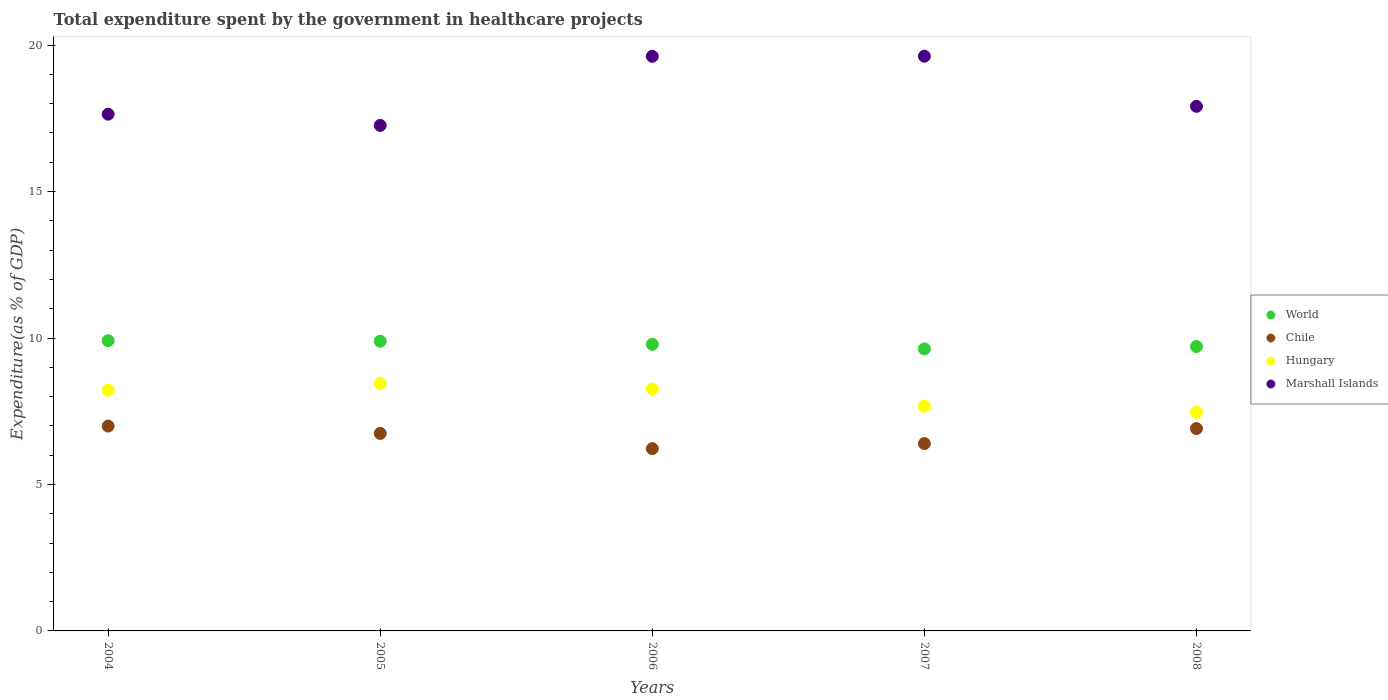How many different coloured dotlines are there?
Offer a very short reply. 4. Is the number of dotlines equal to the number of legend labels?
Provide a succinct answer. Yes. What is the total expenditure spent by the government in healthcare projects in Hungary in 2007?
Keep it short and to the point. 7.67. Across all years, what is the maximum total expenditure spent by the government in healthcare projects in Hungary?
Your answer should be compact. 8.45. Across all years, what is the minimum total expenditure spent by the government in healthcare projects in Marshall Islands?
Your answer should be compact. 17.26. What is the total total expenditure spent by the government in healthcare projects in Marshall Islands in the graph?
Your response must be concise. 92.04. What is the difference between the total expenditure spent by the government in healthcare projects in Chile in 2007 and that in 2008?
Provide a succinct answer. -0.51. What is the difference between the total expenditure spent by the government in healthcare projects in Marshall Islands in 2005 and the total expenditure spent by the government in healthcare projects in World in 2007?
Offer a terse response. 7.63. What is the average total expenditure spent by the government in healthcare projects in Chile per year?
Your answer should be compact. 6.65. In the year 2005, what is the difference between the total expenditure spent by the government in healthcare projects in World and total expenditure spent by the government in healthcare projects in Hungary?
Your response must be concise. 1.45. In how many years, is the total expenditure spent by the government in healthcare projects in Chile greater than 18 %?
Make the answer very short. 0. What is the ratio of the total expenditure spent by the government in healthcare projects in Marshall Islands in 2007 to that in 2008?
Your answer should be very brief. 1.1. Is the difference between the total expenditure spent by the government in healthcare projects in World in 2006 and 2007 greater than the difference between the total expenditure spent by the government in healthcare projects in Hungary in 2006 and 2007?
Your answer should be compact. No. What is the difference between the highest and the second highest total expenditure spent by the government in healthcare projects in World?
Offer a terse response. 0.02. What is the difference between the highest and the lowest total expenditure spent by the government in healthcare projects in Marshall Islands?
Make the answer very short. 2.36. Is the sum of the total expenditure spent by the government in healthcare projects in Chile in 2006 and 2008 greater than the maximum total expenditure spent by the government in healthcare projects in Hungary across all years?
Make the answer very short. Yes. Is it the case that in every year, the sum of the total expenditure spent by the government in healthcare projects in Chile and total expenditure spent by the government in healthcare projects in Marshall Islands  is greater than the total expenditure spent by the government in healthcare projects in Hungary?
Ensure brevity in your answer.  Yes. Does the total expenditure spent by the government in healthcare projects in World monotonically increase over the years?
Provide a succinct answer. No. Is the total expenditure spent by the government in healthcare projects in Chile strictly greater than the total expenditure spent by the government in healthcare projects in World over the years?
Give a very brief answer. No. Is the total expenditure spent by the government in healthcare projects in Chile strictly less than the total expenditure spent by the government in healthcare projects in Hungary over the years?
Your response must be concise. Yes. Are the values on the major ticks of Y-axis written in scientific E-notation?
Give a very brief answer. No. Does the graph contain grids?
Make the answer very short. No. Where does the legend appear in the graph?
Your answer should be very brief. Center right. How are the legend labels stacked?
Make the answer very short. Vertical. What is the title of the graph?
Your answer should be compact. Total expenditure spent by the government in healthcare projects. What is the label or title of the Y-axis?
Provide a short and direct response. Expenditure(as % of GDP). What is the Expenditure(as % of GDP) of World in 2004?
Ensure brevity in your answer.  9.91. What is the Expenditure(as % of GDP) of Chile in 2004?
Give a very brief answer. 6.99. What is the Expenditure(as % of GDP) of Hungary in 2004?
Offer a very short reply. 8.22. What is the Expenditure(as % of GDP) of Marshall Islands in 2004?
Ensure brevity in your answer.  17.64. What is the Expenditure(as % of GDP) of World in 2005?
Ensure brevity in your answer.  9.89. What is the Expenditure(as % of GDP) in Chile in 2005?
Keep it short and to the point. 6.74. What is the Expenditure(as % of GDP) in Hungary in 2005?
Keep it short and to the point. 8.45. What is the Expenditure(as % of GDP) in Marshall Islands in 2005?
Make the answer very short. 17.26. What is the Expenditure(as % of GDP) of World in 2006?
Provide a succinct answer. 9.78. What is the Expenditure(as % of GDP) in Chile in 2006?
Give a very brief answer. 6.22. What is the Expenditure(as % of GDP) of Hungary in 2006?
Your answer should be very brief. 8.26. What is the Expenditure(as % of GDP) in Marshall Islands in 2006?
Provide a succinct answer. 19.62. What is the Expenditure(as % of GDP) of World in 2007?
Give a very brief answer. 9.63. What is the Expenditure(as % of GDP) in Chile in 2007?
Your answer should be very brief. 6.4. What is the Expenditure(as % of GDP) in Hungary in 2007?
Your answer should be compact. 7.67. What is the Expenditure(as % of GDP) of Marshall Islands in 2007?
Give a very brief answer. 19.62. What is the Expenditure(as % of GDP) in World in 2008?
Your answer should be very brief. 9.71. What is the Expenditure(as % of GDP) in Chile in 2008?
Offer a terse response. 6.91. What is the Expenditure(as % of GDP) in Hungary in 2008?
Give a very brief answer. 7.46. What is the Expenditure(as % of GDP) in Marshall Islands in 2008?
Your answer should be compact. 17.91. Across all years, what is the maximum Expenditure(as % of GDP) of World?
Offer a very short reply. 9.91. Across all years, what is the maximum Expenditure(as % of GDP) of Chile?
Provide a succinct answer. 6.99. Across all years, what is the maximum Expenditure(as % of GDP) in Hungary?
Provide a succinct answer. 8.45. Across all years, what is the maximum Expenditure(as % of GDP) in Marshall Islands?
Your answer should be very brief. 19.62. Across all years, what is the minimum Expenditure(as % of GDP) of World?
Make the answer very short. 9.63. Across all years, what is the minimum Expenditure(as % of GDP) of Chile?
Provide a short and direct response. 6.22. Across all years, what is the minimum Expenditure(as % of GDP) in Hungary?
Your answer should be very brief. 7.46. Across all years, what is the minimum Expenditure(as % of GDP) in Marshall Islands?
Provide a short and direct response. 17.26. What is the total Expenditure(as % of GDP) of World in the graph?
Your answer should be very brief. 48.92. What is the total Expenditure(as % of GDP) of Chile in the graph?
Your answer should be very brief. 33.26. What is the total Expenditure(as % of GDP) in Hungary in the graph?
Offer a terse response. 40.06. What is the total Expenditure(as % of GDP) of Marshall Islands in the graph?
Your answer should be compact. 92.04. What is the difference between the Expenditure(as % of GDP) of World in 2004 and that in 2005?
Your answer should be compact. 0.02. What is the difference between the Expenditure(as % of GDP) of Chile in 2004 and that in 2005?
Provide a succinct answer. 0.25. What is the difference between the Expenditure(as % of GDP) of Hungary in 2004 and that in 2005?
Provide a short and direct response. -0.23. What is the difference between the Expenditure(as % of GDP) in Marshall Islands in 2004 and that in 2005?
Keep it short and to the point. 0.38. What is the difference between the Expenditure(as % of GDP) of World in 2004 and that in 2006?
Keep it short and to the point. 0.12. What is the difference between the Expenditure(as % of GDP) in Chile in 2004 and that in 2006?
Provide a short and direct response. 0.77. What is the difference between the Expenditure(as % of GDP) of Hungary in 2004 and that in 2006?
Keep it short and to the point. -0.04. What is the difference between the Expenditure(as % of GDP) of Marshall Islands in 2004 and that in 2006?
Offer a very short reply. -1.97. What is the difference between the Expenditure(as % of GDP) of World in 2004 and that in 2007?
Ensure brevity in your answer.  0.28. What is the difference between the Expenditure(as % of GDP) in Chile in 2004 and that in 2007?
Give a very brief answer. 0.6. What is the difference between the Expenditure(as % of GDP) of Hungary in 2004 and that in 2007?
Offer a very short reply. 0.54. What is the difference between the Expenditure(as % of GDP) in Marshall Islands in 2004 and that in 2007?
Your answer should be compact. -1.98. What is the difference between the Expenditure(as % of GDP) in Chile in 2004 and that in 2008?
Provide a succinct answer. 0.09. What is the difference between the Expenditure(as % of GDP) of Hungary in 2004 and that in 2008?
Make the answer very short. 0.76. What is the difference between the Expenditure(as % of GDP) in Marshall Islands in 2004 and that in 2008?
Provide a short and direct response. -0.27. What is the difference between the Expenditure(as % of GDP) of World in 2005 and that in 2006?
Your answer should be compact. 0.11. What is the difference between the Expenditure(as % of GDP) in Chile in 2005 and that in 2006?
Your response must be concise. 0.52. What is the difference between the Expenditure(as % of GDP) of Hungary in 2005 and that in 2006?
Make the answer very short. 0.19. What is the difference between the Expenditure(as % of GDP) of Marshall Islands in 2005 and that in 2006?
Keep it short and to the point. -2.36. What is the difference between the Expenditure(as % of GDP) of World in 2005 and that in 2007?
Make the answer very short. 0.26. What is the difference between the Expenditure(as % of GDP) in Chile in 2005 and that in 2007?
Your response must be concise. 0.35. What is the difference between the Expenditure(as % of GDP) of Hungary in 2005 and that in 2007?
Your answer should be compact. 0.77. What is the difference between the Expenditure(as % of GDP) of Marshall Islands in 2005 and that in 2007?
Ensure brevity in your answer.  -2.36. What is the difference between the Expenditure(as % of GDP) in World in 2005 and that in 2008?
Keep it short and to the point. 0.18. What is the difference between the Expenditure(as % of GDP) in Chile in 2005 and that in 2008?
Offer a very short reply. -0.16. What is the difference between the Expenditure(as % of GDP) in Hungary in 2005 and that in 2008?
Give a very brief answer. 0.98. What is the difference between the Expenditure(as % of GDP) in Marshall Islands in 2005 and that in 2008?
Offer a very short reply. -0.65. What is the difference between the Expenditure(as % of GDP) of World in 2006 and that in 2007?
Your response must be concise. 0.16. What is the difference between the Expenditure(as % of GDP) in Chile in 2006 and that in 2007?
Keep it short and to the point. -0.17. What is the difference between the Expenditure(as % of GDP) in Hungary in 2006 and that in 2007?
Provide a succinct answer. 0.58. What is the difference between the Expenditure(as % of GDP) in Marshall Islands in 2006 and that in 2007?
Make the answer very short. -0. What is the difference between the Expenditure(as % of GDP) in World in 2006 and that in 2008?
Your answer should be very brief. 0.08. What is the difference between the Expenditure(as % of GDP) in Chile in 2006 and that in 2008?
Your answer should be compact. -0.68. What is the difference between the Expenditure(as % of GDP) in Hungary in 2006 and that in 2008?
Give a very brief answer. 0.8. What is the difference between the Expenditure(as % of GDP) of Marshall Islands in 2006 and that in 2008?
Offer a terse response. 1.71. What is the difference between the Expenditure(as % of GDP) of World in 2007 and that in 2008?
Provide a succinct answer. -0.08. What is the difference between the Expenditure(as % of GDP) of Chile in 2007 and that in 2008?
Provide a short and direct response. -0.51. What is the difference between the Expenditure(as % of GDP) of Hungary in 2007 and that in 2008?
Make the answer very short. 0.21. What is the difference between the Expenditure(as % of GDP) of Marshall Islands in 2007 and that in 2008?
Keep it short and to the point. 1.71. What is the difference between the Expenditure(as % of GDP) of World in 2004 and the Expenditure(as % of GDP) of Chile in 2005?
Offer a terse response. 3.16. What is the difference between the Expenditure(as % of GDP) in World in 2004 and the Expenditure(as % of GDP) in Hungary in 2005?
Offer a very short reply. 1.46. What is the difference between the Expenditure(as % of GDP) in World in 2004 and the Expenditure(as % of GDP) in Marshall Islands in 2005?
Your answer should be very brief. -7.35. What is the difference between the Expenditure(as % of GDP) in Chile in 2004 and the Expenditure(as % of GDP) in Hungary in 2005?
Make the answer very short. -1.45. What is the difference between the Expenditure(as % of GDP) in Chile in 2004 and the Expenditure(as % of GDP) in Marshall Islands in 2005?
Provide a short and direct response. -10.26. What is the difference between the Expenditure(as % of GDP) of Hungary in 2004 and the Expenditure(as % of GDP) of Marshall Islands in 2005?
Your answer should be very brief. -9.04. What is the difference between the Expenditure(as % of GDP) of World in 2004 and the Expenditure(as % of GDP) of Chile in 2006?
Offer a very short reply. 3.69. What is the difference between the Expenditure(as % of GDP) of World in 2004 and the Expenditure(as % of GDP) of Hungary in 2006?
Provide a succinct answer. 1.65. What is the difference between the Expenditure(as % of GDP) of World in 2004 and the Expenditure(as % of GDP) of Marshall Islands in 2006?
Your response must be concise. -9.71. What is the difference between the Expenditure(as % of GDP) in Chile in 2004 and the Expenditure(as % of GDP) in Hungary in 2006?
Your answer should be very brief. -1.27. What is the difference between the Expenditure(as % of GDP) in Chile in 2004 and the Expenditure(as % of GDP) in Marshall Islands in 2006?
Make the answer very short. -12.62. What is the difference between the Expenditure(as % of GDP) in Hungary in 2004 and the Expenditure(as % of GDP) in Marshall Islands in 2006?
Make the answer very short. -11.4. What is the difference between the Expenditure(as % of GDP) in World in 2004 and the Expenditure(as % of GDP) in Chile in 2007?
Provide a succinct answer. 3.51. What is the difference between the Expenditure(as % of GDP) in World in 2004 and the Expenditure(as % of GDP) in Hungary in 2007?
Make the answer very short. 2.23. What is the difference between the Expenditure(as % of GDP) of World in 2004 and the Expenditure(as % of GDP) of Marshall Islands in 2007?
Your answer should be compact. -9.71. What is the difference between the Expenditure(as % of GDP) in Chile in 2004 and the Expenditure(as % of GDP) in Hungary in 2007?
Offer a terse response. -0.68. What is the difference between the Expenditure(as % of GDP) of Chile in 2004 and the Expenditure(as % of GDP) of Marshall Islands in 2007?
Keep it short and to the point. -12.63. What is the difference between the Expenditure(as % of GDP) in Hungary in 2004 and the Expenditure(as % of GDP) in Marshall Islands in 2007?
Your answer should be compact. -11.4. What is the difference between the Expenditure(as % of GDP) in World in 2004 and the Expenditure(as % of GDP) in Chile in 2008?
Offer a very short reply. 3. What is the difference between the Expenditure(as % of GDP) in World in 2004 and the Expenditure(as % of GDP) in Hungary in 2008?
Provide a succinct answer. 2.44. What is the difference between the Expenditure(as % of GDP) in World in 2004 and the Expenditure(as % of GDP) in Marshall Islands in 2008?
Offer a very short reply. -8. What is the difference between the Expenditure(as % of GDP) in Chile in 2004 and the Expenditure(as % of GDP) in Hungary in 2008?
Provide a succinct answer. -0.47. What is the difference between the Expenditure(as % of GDP) of Chile in 2004 and the Expenditure(as % of GDP) of Marshall Islands in 2008?
Ensure brevity in your answer.  -10.92. What is the difference between the Expenditure(as % of GDP) of Hungary in 2004 and the Expenditure(as % of GDP) of Marshall Islands in 2008?
Offer a terse response. -9.69. What is the difference between the Expenditure(as % of GDP) in World in 2005 and the Expenditure(as % of GDP) in Chile in 2006?
Ensure brevity in your answer.  3.67. What is the difference between the Expenditure(as % of GDP) in World in 2005 and the Expenditure(as % of GDP) in Hungary in 2006?
Your response must be concise. 1.63. What is the difference between the Expenditure(as % of GDP) of World in 2005 and the Expenditure(as % of GDP) of Marshall Islands in 2006?
Give a very brief answer. -9.73. What is the difference between the Expenditure(as % of GDP) in Chile in 2005 and the Expenditure(as % of GDP) in Hungary in 2006?
Your response must be concise. -1.52. What is the difference between the Expenditure(as % of GDP) of Chile in 2005 and the Expenditure(as % of GDP) of Marshall Islands in 2006?
Ensure brevity in your answer.  -12.87. What is the difference between the Expenditure(as % of GDP) of Hungary in 2005 and the Expenditure(as % of GDP) of Marshall Islands in 2006?
Provide a succinct answer. -11.17. What is the difference between the Expenditure(as % of GDP) in World in 2005 and the Expenditure(as % of GDP) in Chile in 2007?
Keep it short and to the point. 3.49. What is the difference between the Expenditure(as % of GDP) in World in 2005 and the Expenditure(as % of GDP) in Hungary in 2007?
Your answer should be very brief. 2.22. What is the difference between the Expenditure(as % of GDP) in World in 2005 and the Expenditure(as % of GDP) in Marshall Islands in 2007?
Your answer should be compact. -9.73. What is the difference between the Expenditure(as % of GDP) in Chile in 2005 and the Expenditure(as % of GDP) in Hungary in 2007?
Offer a terse response. -0.93. What is the difference between the Expenditure(as % of GDP) in Chile in 2005 and the Expenditure(as % of GDP) in Marshall Islands in 2007?
Your answer should be very brief. -12.88. What is the difference between the Expenditure(as % of GDP) in Hungary in 2005 and the Expenditure(as % of GDP) in Marshall Islands in 2007?
Make the answer very short. -11.17. What is the difference between the Expenditure(as % of GDP) in World in 2005 and the Expenditure(as % of GDP) in Chile in 2008?
Your answer should be very brief. 2.98. What is the difference between the Expenditure(as % of GDP) in World in 2005 and the Expenditure(as % of GDP) in Hungary in 2008?
Provide a succinct answer. 2.43. What is the difference between the Expenditure(as % of GDP) of World in 2005 and the Expenditure(as % of GDP) of Marshall Islands in 2008?
Give a very brief answer. -8.02. What is the difference between the Expenditure(as % of GDP) of Chile in 2005 and the Expenditure(as % of GDP) of Hungary in 2008?
Your response must be concise. -0.72. What is the difference between the Expenditure(as % of GDP) in Chile in 2005 and the Expenditure(as % of GDP) in Marshall Islands in 2008?
Give a very brief answer. -11.16. What is the difference between the Expenditure(as % of GDP) in Hungary in 2005 and the Expenditure(as % of GDP) in Marshall Islands in 2008?
Keep it short and to the point. -9.46. What is the difference between the Expenditure(as % of GDP) in World in 2006 and the Expenditure(as % of GDP) in Chile in 2007?
Offer a very short reply. 3.39. What is the difference between the Expenditure(as % of GDP) of World in 2006 and the Expenditure(as % of GDP) of Hungary in 2007?
Offer a very short reply. 2.11. What is the difference between the Expenditure(as % of GDP) of World in 2006 and the Expenditure(as % of GDP) of Marshall Islands in 2007?
Give a very brief answer. -9.84. What is the difference between the Expenditure(as % of GDP) in Chile in 2006 and the Expenditure(as % of GDP) in Hungary in 2007?
Ensure brevity in your answer.  -1.45. What is the difference between the Expenditure(as % of GDP) in Chile in 2006 and the Expenditure(as % of GDP) in Marshall Islands in 2007?
Your response must be concise. -13.4. What is the difference between the Expenditure(as % of GDP) in Hungary in 2006 and the Expenditure(as % of GDP) in Marshall Islands in 2007?
Provide a succinct answer. -11.36. What is the difference between the Expenditure(as % of GDP) in World in 2006 and the Expenditure(as % of GDP) in Chile in 2008?
Your response must be concise. 2.88. What is the difference between the Expenditure(as % of GDP) in World in 2006 and the Expenditure(as % of GDP) in Hungary in 2008?
Your response must be concise. 2.32. What is the difference between the Expenditure(as % of GDP) in World in 2006 and the Expenditure(as % of GDP) in Marshall Islands in 2008?
Give a very brief answer. -8.12. What is the difference between the Expenditure(as % of GDP) in Chile in 2006 and the Expenditure(as % of GDP) in Hungary in 2008?
Provide a succinct answer. -1.24. What is the difference between the Expenditure(as % of GDP) of Chile in 2006 and the Expenditure(as % of GDP) of Marshall Islands in 2008?
Keep it short and to the point. -11.69. What is the difference between the Expenditure(as % of GDP) of Hungary in 2006 and the Expenditure(as % of GDP) of Marshall Islands in 2008?
Offer a very short reply. -9.65. What is the difference between the Expenditure(as % of GDP) in World in 2007 and the Expenditure(as % of GDP) in Chile in 2008?
Your answer should be very brief. 2.72. What is the difference between the Expenditure(as % of GDP) in World in 2007 and the Expenditure(as % of GDP) in Hungary in 2008?
Keep it short and to the point. 2.16. What is the difference between the Expenditure(as % of GDP) in World in 2007 and the Expenditure(as % of GDP) in Marshall Islands in 2008?
Offer a very short reply. -8.28. What is the difference between the Expenditure(as % of GDP) in Chile in 2007 and the Expenditure(as % of GDP) in Hungary in 2008?
Provide a short and direct response. -1.07. What is the difference between the Expenditure(as % of GDP) in Chile in 2007 and the Expenditure(as % of GDP) in Marshall Islands in 2008?
Offer a terse response. -11.51. What is the difference between the Expenditure(as % of GDP) of Hungary in 2007 and the Expenditure(as % of GDP) of Marshall Islands in 2008?
Your answer should be compact. -10.23. What is the average Expenditure(as % of GDP) in World per year?
Offer a terse response. 9.78. What is the average Expenditure(as % of GDP) of Chile per year?
Offer a very short reply. 6.65. What is the average Expenditure(as % of GDP) of Hungary per year?
Your answer should be compact. 8.01. What is the average Expenditure(as % of GDP) in Marshall Islands per year?
Offer a terse response. 18.41. In the year 2004, what is the difference between the Expenditure(as % of GDP) of World and Expenditure(as % of GDP) of Chile?
Provide a succinct answer. 2.91. In the year 2004, what is the difference between the Expenditure(as % of GDP) in World and Expenditure(as % of GDP) in Hungary?
Offer a terse response. 1.69. In the year 2004, what is the difference between the Expenditure(as % of GDP) in World and Expenditure(as % of GDP) in Marshall Islands?
Your response must be concise. -7.73. In the year 2004, what is the difference between the Expenditure(as % of GDP) of Chile and Expenditure(as % of GDP) of Hungary?
Your answer should be compact. -1.23. In the year 2004, what is the difference between the Expenditure(as % of GDP) of Chile and Expenditure(as % of GDP) of Marshall Islands?
Give a very brief answer. -10.65. In the year 2004, what is the difference between the Expenditure(as % of GDP) in Hungary and Expenditure(as % of GDP) in Marshall Islands?
Offer a very short reply. -9.42. In the year 2005, what is the difference between the Expenditure(as % of GDP) of World and Expenditure(as % of GDP) of Chile?
Provide a succinct answer. 3.15. In the year 2005, what is the difference between the Expenditure(as % of GDP) of World and Expenditure(as % of GDP) of Hungary?
Provide a short and direct response. 1.45. In the year 2005, what is the difference between the Expenditure(as % of GDP) in World and Expenditure(as % of GDP) in Marshall Islands?
Your answer should be compact. -7.37. In the year 2005, what is the difference between the Expenditure(as % of GDP) of Chile and Expenditure(as % of GDP) of Hungary?
Provide a succinct answer. -1.7. In the year 2005, what is the difference between the Expenditure(as % of GDP) in Chile and Expenditure(as % of GDP) in Marshall Islands?
Offer a terse response. -10.51. In the year 2005, what is the difference between the Expenditure(as % of GDP) in Hungary and Expenditure(as % of GDP) in Marshall Islands?
Your answer should be very brief. -8.81. In the year 2006, what is the difference between the Expenditure(as % of GDP) of World and Expenditure(as % of GDP) of Chile?
Make the answer very short. 3.56. In the year 2006, what is the difference between the Expenditure(as % of GDP) of World and Expenditure(as % of GDP) of Hungary?
Offer a terse response. 1.53. In the year 2006, what is the difference between the Expenditure(as % of GDP) of World and Expenditure(as % of GDP) of Marshall Islands?
Make the answer very short. -9.83. In the year 2006, what is the difference between the Expenditure(as % of GDP) in Chile and Expenditure(as % of GDP) in Hungary?
Make the answer very short. -2.04. In the year 2006, what is the difference between the Expenditure(as % of GDP) in Chile and Expenditure(as % of GDP) in Marshall Islands?
Keep it short and to the point. -13.39. In the year 2006, what is the difference between the Expenditure(as % of GDP) of Hungary and Expenditure(as % of GDP) of Marshall Islands?
Your answer should be very brief. -11.36. In the year 2007, what is the difference between the Expenditure(as % of GDP) in World and Expenditure(as % of GDP) in Chile?
Keep it short and to the point. 3.23. In the year 2007, what is the difference between the Expenditure(as % of GDP) of World and Expenditure(as % of GDP) of Hungary?
Give a very brief answer. 1.95. In the year 2007, what is the difference between the Expenditure(as % of GDP) in World and Expenditure(as % of GDP) in Marshall Islands?
Give a very brief answer. -9.99. In the year 2007, what is the difference between the Expenditure(as % of GDP) of Chile and Expenditure(as % of GDP) of Hungary?
Offer a terse response. -1.28. In the year 2007, what is the difference between the Expenditure(as % of GDP) of Chile and Expenditure(as % of GDP) of Marshall Islands?
Provide a short and direct response. -13.22. In the year 2007, what is the difference between the Expenditure(as % of GDP) in Hungary and Expenditure(as % of GDP) in Marshall Islands?
Your answer should be very brief. -11.95. In the year 2008, what is the difference between the Expenditure(as % of GDP) in World and Expenditure(as % of GDP) in Chile?
Provide a succinct answer. 2.8. In the year 2008, what is the difference between the Expenditure(as % of GDP) in World and Expenditure(as % of GDP) in Hungary?
Give a very brief answer. 2.24. In the year 2008, what is the difference between the Expenditure(as % of GDP) in World and Expenditure(as % of GDP) in Marshall Islands?
Your response must be concise. -8.2. In the year 2008, what is the difference between the Expenditure(as % of GDP) in Chile and Expenditure(as % of GDP) in Hungary?
Give a very brief answer. -0.56. In the year 2008, what is the difference between the Expenditure(as % of GDP) of Chile and Expenditure(as % of GDP) of Marshall Islands?
Your answer should be very brief. -11. In the year 2008, what is the difference between the Expenditure(as % of GDP) of Hungary and Expenditure(as % of GDP) of Marshall Islands?
Provide a short and direct response. -10.45. What is the ratio of the Expenditure(as % of GDP) in World in 2004 to that in 2005?
Your answer should be compact. 1. What is the ratio of the Expenditure(as % of GDP) in Chile in 2004 to that in 2005?
Offer a very short reply. 1.04. What is the ratio of the Expenditure(as % of GDP) of Hungary in 2004 to that in 2005?
Your response must be concise. 0.97. What is the ratio of the Expenditure(as % of GDP) in Marshall Islands in 2004 to that in 2005?
Provide a succinct answer. 1.02. What is the ratio of the Expenditure(as % of GDP) of World in 2004 to that in 2006?
Give a very brief answer. 1.01. What is the ratio of the Expenditure(as % of GDP) in Chile in 2004 to that in 2006?
Keep it short and to the point. 1.12. What is the ratio of the Expenditure(as % of GDP) of Hungary in 2004 to that in 2006?
Offer a very short reply. 1. What is the ratio of the Expenditure(as % of GDP) in Marshall Islands in 2004 to that in 2006?
Give a very brief answer. 0.9. What is the ratio of the Expenditure(as % of GDP) of World in 2004 to that in 2007?
Provide a succinct answer. 1.03. What is the ratio of the Expenditure(as % of GDP) of Chile in 2004 to that in 2007?
Provide a succinct answer. 1.09. What is the ratio of the Expenditure(as % of GDP) in Hungary in 2004 to that in 2007?
Your response must be concise. 1.07. What is the ratio of the Expenditure(as % of GDP) in Marshall Islands in 2004 to that in 2007?
Your answer should be very brief. 0.9. What is the ratio of the Expenditure(as % of GDP) in World in 2004 to that in 2008?
Offer a very short reply. 1.02. What is the ratio of the Expenditure(as % of GDP) of Chile in 2004 to that in 2008?
Keep it short and to the point. 1.01. What is the ratio of the Expenditure(as % of GDP) in Hungary in 2004 to that in 2008?
Give a very brief answer. 1.1. What is the ratio of the Expenditure(as % of GDP) of Marshall Islands in 2004 to that in 2008?
Provide a succinct answer. 0.99. What is the ratio of the Expenditure(as % of GDP) in World in 2005 to that in 2006?
Ensure brevity in your answer.  1.01. What is the ratio of the Expenditure(as % of GDP) of Chile in 2005 to that in 2006?
Provide a short and direct response. 1.08. What is the ratio of the Expenditure(as % of GDP) of Hungary in 2005 to that in 2006?
Your answer should be very brief. 1.02. What is the ratio of the Expenditure(as % of GDP) in Marshall Islands in 2005 to that in 2006?
Keep it short and to the point. 0.88. What is the ratio of the Expenditure(as % of GDP) of World in 2005 to that in 2007?
Offer a very short reply. 1.03. What is the ratio of the Expenditure(as % of GDP) in Chile in 2005 to that in 2007?
Ensure brevity in your answer.  1.05. What is the ratio of the Expenditure(as % of GDP) in Hungary in 2005 to that in 2007?
Your answer should be very brief. 1.1. What is the ratio of the Expenditure(as % of GDP) in Marshall Islands in 2005 to that in 2007?
Provide a succinct answer. 0.88. What is the ratio of the Expenditure(as % of GDP) in World in 2005 to that in 2008?
Your answer should be compact. 1.02. What is the ratio of the Expenditure(as % of GDP) of Chile in 2005 to that in 2008?
Give a very brief answer. 0.98. What is the ratio of the Expenditure(as % of GDP) in Hungary in 2005 to that in 2008?
Give a very brief answer. 1.13. What is the ratio of the Expenditure(as % of GDP) of Marshall Islands in 2005 to that in 2008?
Ensure brevity in your answer.  0.96. What is the ratio of the Expenditure(as % of GDP) of World in 2006 to that in 2007?
Offer a very short reply. 1.02. What is the ratio of the Expenditure(as % of GDP) in Chile in 2006 to that in 2007?
Provide a succinct answer. 0.97. What is the ratio of the Expenditure(as % of GDP) of Hungary in 2006 to that in 2007?
Give a very brief answer. 1.08. What is the ratio of the Expenditure(as % of GDP) in Chile in 2006 to that in 2008?
Offer a very short reply. 0.9. What is the ratio of the Expenditure(as % of GDP) in Hungary in 2006 to that in 2008?
Make the answer very short. 1.11. What is the ratio of the Expenditure(as % of GDP) of Marshall Islands in 2006 to that in 2008?
Give a very brief answer. 1.1. What is the ratio of the Expenditure(as % of GDP) of Chile in 2007 to that in 2008?
Provide a succinct answer. 0.93. What is the ratio of the Expenditure(as % of GDP) in Hungary in 2007 to that in 2008?
Your response must be concise. 1.03. What is the ratio of the Expenditure(as % of GDP) of Marshall Islands in 2007 to that in 2008?
Give a very brief answer. 1.1. What is the difference between the highest and the second highest Expenditure(as % of GDP) in World?
Offer a terse response. 0.02. What is the difference between the highest and the second highest Expenditure(as % of GDP) of Chile?
Give a very brief answer. 0.09. What is the difference between the highest and the second highest Expenditure(as % of GDP) of Hungary?
Your answer should be very brief. 0.19. What is the difference between the highest and the second highest Expenditure(as % of GDP) of Marshall Islands?
Offer a terse response. 0. What is the difference between the highest and the lowest Expenditure(as % of GDP) in World?
Give a very brief answer. 0.28. What is the difference between the highest and the lowest Expenditure(as % of GDP) in Chile?
Provide a succinct answer. 0.77. What is the difference between the highest and the lowest Expenditure(as % of GDP) of Hungary?
Give a very brief answer. 0.98. What is the difference between the highest and the lowest Expenditure(as % of GDP) in Marshall Islands?
Your answer should be compact. 2.36. 